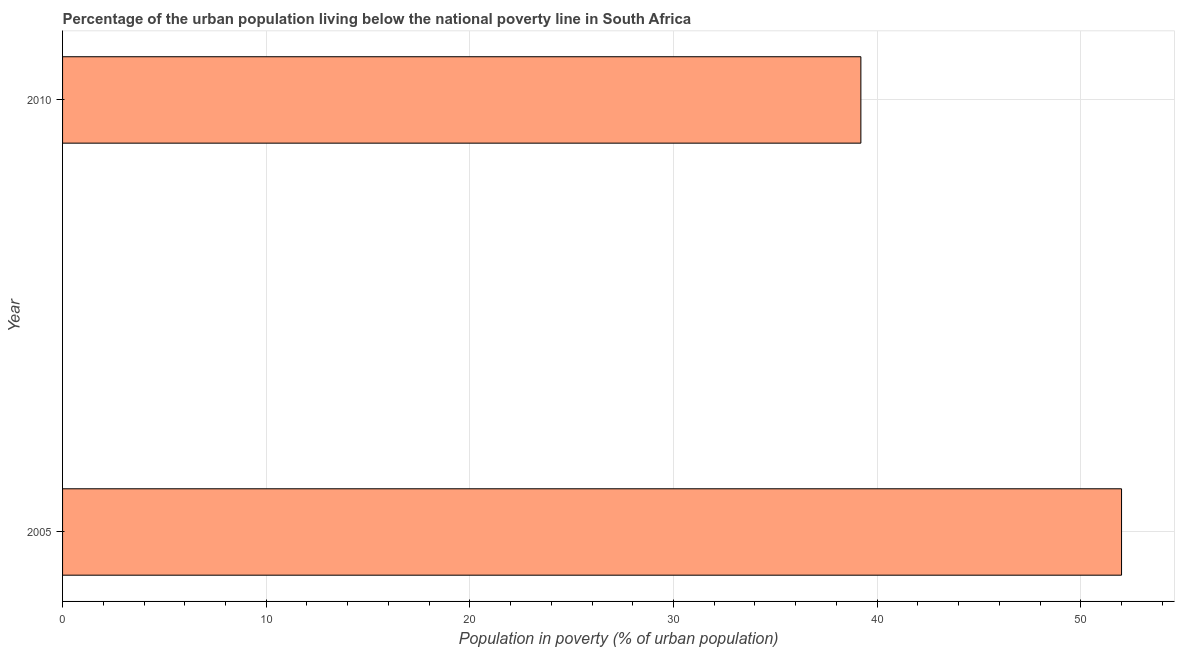Does the graph contain any zero values?
Provide a short and direct response. No. Does the graph contain grids?
Your answer should be compact. Yes. What is the title of the graph?
Give a very brief answer. Percentage of the urban population living below the national poverty line in South Africa. What is the label or title of the X-axis?
Give a very brief answer. Population in poverty (% of urban population). What is the percentage of urban population living below poverty line in 2005?
Offer a very short reply. 52. Across all years, what is the maximum percentage of urban population living below poverty line?
Offer a terse response. 52. Across all years, what is the minimum percentage of urban population living below poverty line?
Offer a terse response. 39.2. What is the sum of the percentage of urban population living below poverty line?
Offer a terse response. 91.2. What is the difference between the percentage of urban population living below poverty line in 2005 and 2010?
Make the answer very short. 12.8. What is the average percentage of urban population living below poverty line per year?
Ensure brevity in your answer.  45.6. What is the median percentage of urban population living below poverty line?
Your answer should be very brief. 45.6. What is the ratio of the percentage of urban population living below poverty line in 2005 to that in 2010?
Offer a very short reply. 1.33. Is the percentage of urban population living below poverty line in 2005 less than that in 2010?
Offer a very short reply. No. How many bars are there?
Provide a succinct answer. 2. Are all the bars in the graph horizontal?
Your response must be concise. Yes. How many years are there in the graph?
Provide a short and direct response. 2. Are the values on the major ticks of X-axis written in scientific E-notation?
Offer a terse response. No. What is the Population in poverty (% of urban population) of 2005?
Make the answer very short. 52. What is the Population in poverty (% of urban population) in 2010?
Your response must be concise. 39.2. What is the difference between the Population in poverty (% of urban population) in 2005 and 2010?
Your response must be concise. 12.8. What is the ratio of the Population in poverty (% of urban population) in 2005 to that in 2010?
Ensure brevity in your answer.  1.33. 